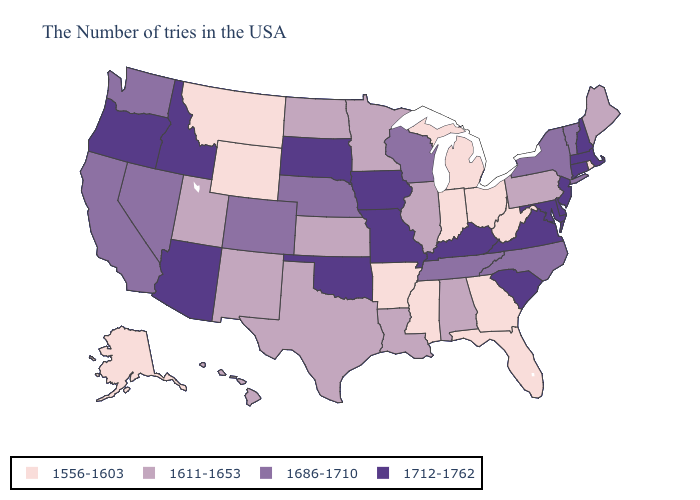Among the states that border Louisiana , does Texas have the lowest value?
Write a very short answer. No. Name the states that have a value in the range 1686-1710?
Write a very short answer. Vermont, New York, North Carolina, Tennessee, Wisconsin, Nebraska, Colorado, Nevada, California, Washington. Name the states that have a value in the range 1556-1603?
Write a very short answer. Rhode Island, West Virginia, Ohio, Florida, Georgia, Michigan, Indiana, Mississippi, Arkansas, Wyoming, Montana, Alaska. Among the states that border Tennessee , which have the lowest value?
Answer briefly. Georgia, Mississippi, Arkansas. What is the lowest value in states that border Iowa?
Write a very short answer. 1611-1653. Name the states that have a value in the range 1611-1653?
Short answer required. Maine, Pennsylvania, Alabama, Illinois, Louisiana, Minnesota, Kansas, Texas, North Dakota, New Mexico, Utah, Hawaii. Among the states that border Michigan , does Wisconsin have the lowest value?
Give a very brief answer. No. What is the value of Maryland?
Short answer required. 1712-1762. What is the highest value in the USA?
Give a very brief answer. 1712-1762. Which states have the lowest value in the South?
Concise answer only. West Virginia, Florida, Georgia, Mississippi, Arkansas. Name the states that have a value in the range 1556-1603?
Give a very brief answer. Rhode Island, West Virginia, Ohio, Florida, Georgia, Michigan, Indiana, Mississippi, Arkansas, Wyoming, Montana, Alaska. Name the states that have a value in the range 1556-1603?
Short answer required. Rhode Island, West Virginia, Ohio, Florida, Georgia, Michigan, Indiana, Mississippi, Arkansas, Wyoming, Montana, Alaska. What is the value of North Dakota?
Concise answer only. 1611-1653. What is the value of New Hampshire?
Keep it brief. 1712-1762. Which states have the highest value in the USA?
Write a very short answer. Massachusetts, New Hampshire, Connecticut, New Jersey, Delaware, Maryland, Virginia, South Carolina, Kentucky, Missouri, Iowa, Oklahoma, South Dakota, Arizona, Idaho, Oregon. 